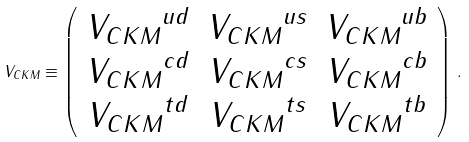<formula> <loc_0><loc_0><loc_500><loc_500>V _ { C K M } \equiv \left ( \begin{array} { c c c } { V _ { C K M } } ^ { u d } & { V _ { C K M } } ^ { u s } & { V _ { C K M } } ^ { u b } \\ { V _ { C K M } } ^ { c d } & { V _ { C K M } } ^ { c s } & { V _ { C K M } } ^ { c b } \\ { V _ { C K M } } ^ { t d } & { V _ { C K M } } ^ { t s } & { V _ { C K M } } ^ { t b } \end{array} \right ) \, .</formula> 